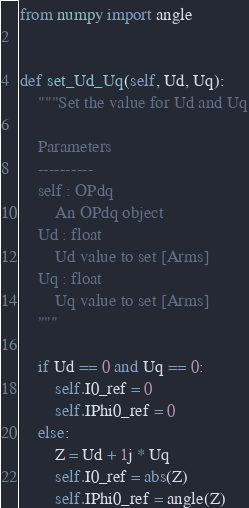<code> <loc_0><loc_0><loc_500><loc_500><_Python_>from numpy import angle


def set_Ud_Uq(self, Ud, Uq):
    """Set the value for Ud and Uq

    Parameters
    ----------
    self : OPdq
        An OPdq object
    Ud : float
        Ud value to set [Arms]
    Uq : float
        Uq value to set [Arms]
    """

    if Ud == 0 and Uq == 0:
        self.I0_ref = 0
        self.IPhi0_ref = 0
    else:
        Z = Ud + 1j * Uq
        self.I0_ref = abs(Z)
        self.IPhi0_ref = angle(Z)
</code> 